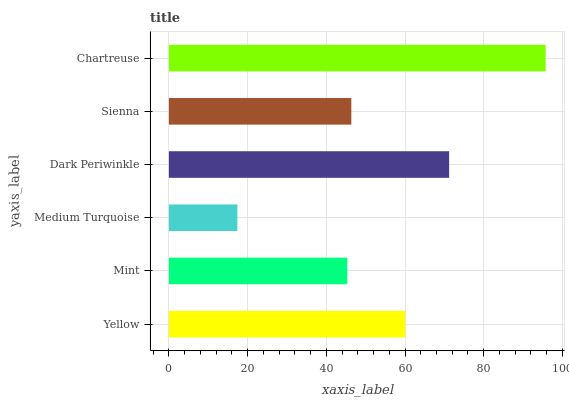Is Medium Turquoise the minimum?
Answer yes or no. Yes. Is Chartreuse the maximum?
Answer yes or no. Yes. Is Mint the minimum?
Answer yes or no. No. Is Mint the maximum?
Answer yes or no. No. Is Yellow greater than Mint?
Answer yes or no. Yes. Is Mint less than Yellow?
Answer yes or no. Yes. Is Mint greater than Yellow?
Answer yes or no. No. Is Yellow less than Mint?
Answer yes or no. No. Is Yellow the high median?
Answer yes or no. Yes. Is Sienna the low median?
Answer yes or no. Yes. Is Mint the high median?
Answer yes or no. No. Is Yellow the low median?
Answer yes or no. No. 